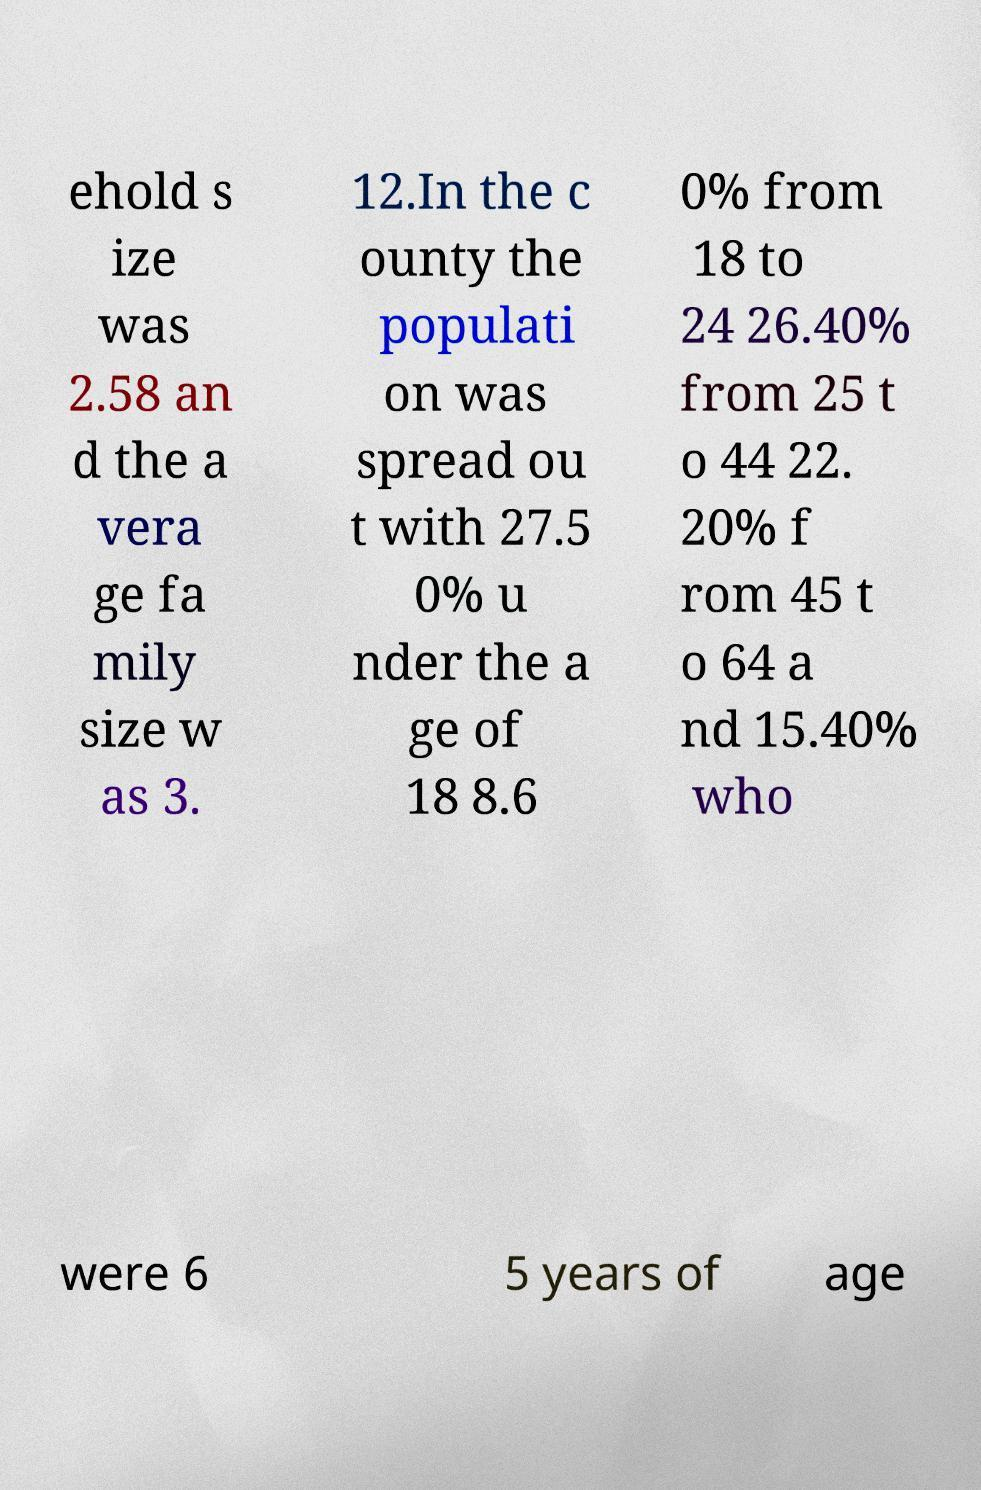I need the written content from this picture converted into text. Can you do that? ehold s ize was 2.58 an d the a vera ge fa mily size w as 3. 12.In the c ounty the populati on was spread ou t with 27.5 0% u nder the a ge of 18 8.6 0% from 18 to 24 26.40% from 25 t o 44 22. 20% f rom 45 t o 64 a nd 15.40% who were 6 5 years of age 